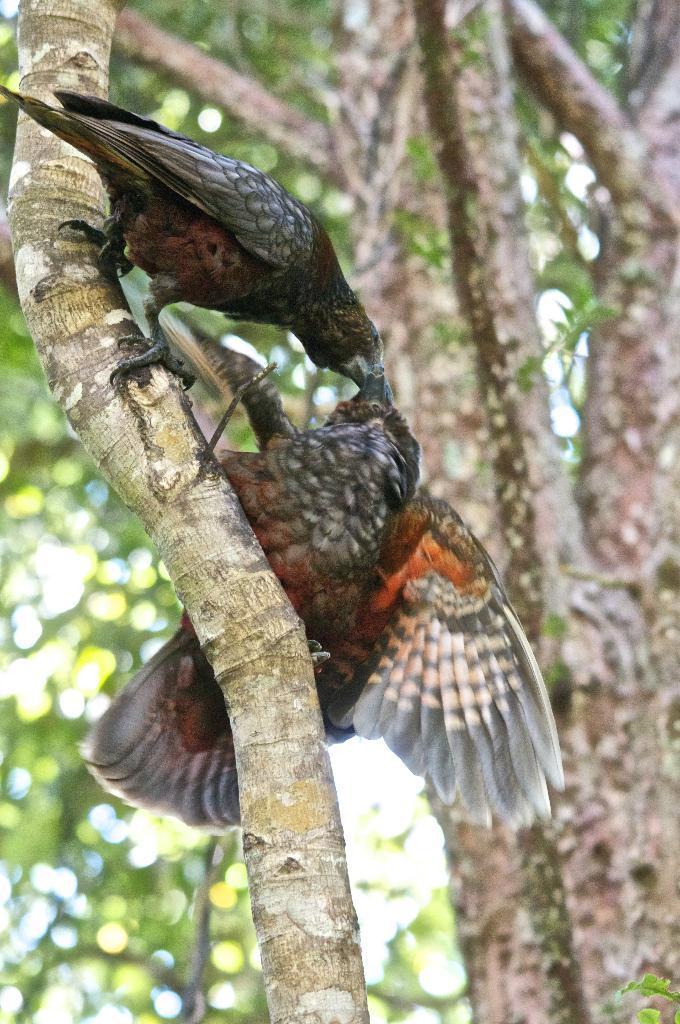How would you summarize this image in a sentence or two? In this image there are two birds standing on the branch, and in the background there is tree. 